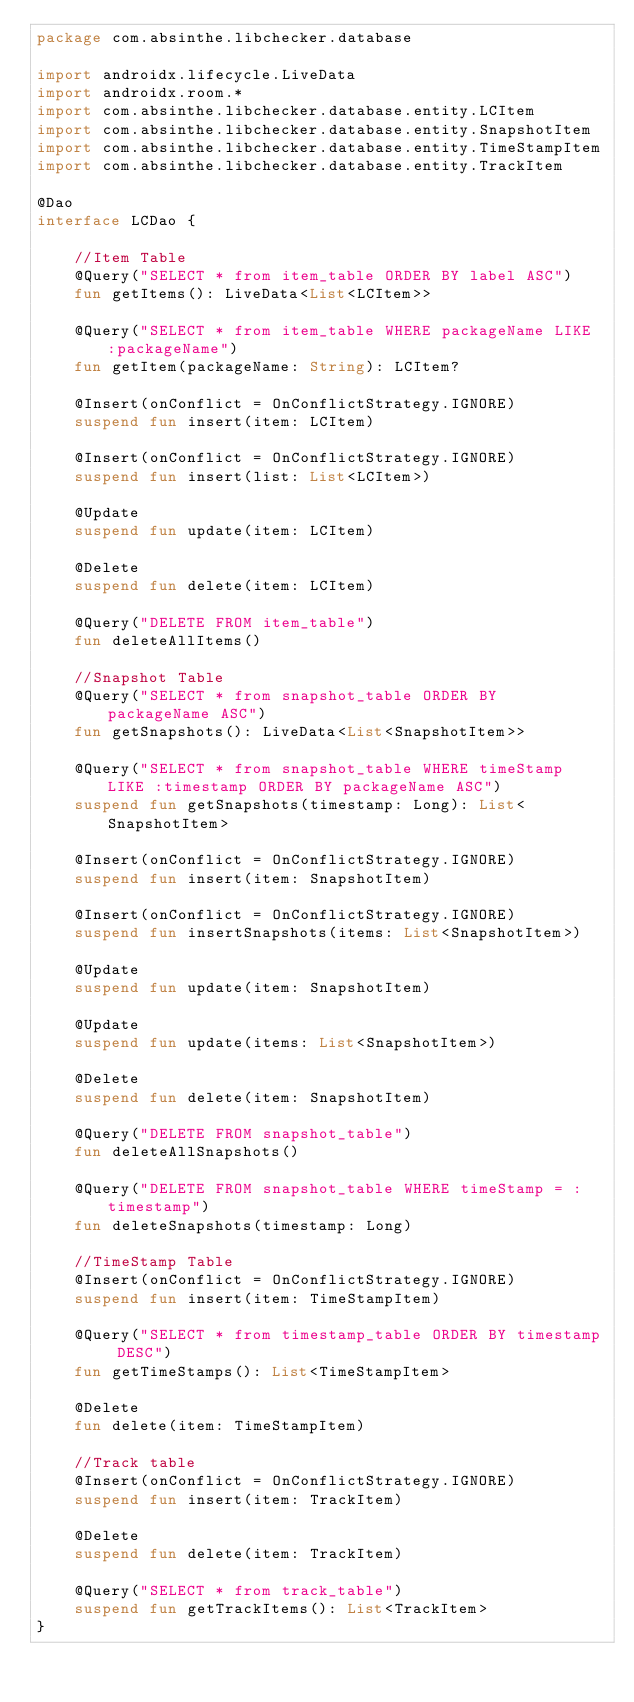<code> <loc_0><loc_0><loc_500><loc_500><_Kotlin_>package com.absinthe.libchecker.database

import androidx.lifecycle.LiveData
import androidx.room.*
import com.absinthe.libchecker.database.entity.LCItem
import com.absinthe.libchecker.database.entity.SnapshotItem
import com.absinthe.libchecker.database.entity.TimeStampItem
import com.absinthe.libchecker.database.entity.TrackItem

@Dao
interface LCDao {

    //Item Table
    @Query("SELECT * from item_table ORDER BY label ASC")
    fun getItems(): LiveData<List<LCItem>>

    @Query("SELECT * from item_table WHERE packageName LIKE :packageName")
    fun getItem(packageName: String): LCItem?

    @Insert(onConflict = OnConflictStrategy.IGNORE)
    suspend fun insert(item: LCItem)

    @Insert(onConflict = OnConflictStrategy.IGNORE)
    suspend fun insert(list: List<LCItem>)

    @Update
    suspend fun update(item: LCItem)

    @Delete
    suspend fun delete(item: LCItem)

    @Query("DELETE FROM item_table")
    fun deleteAllItems()

    //Snapshot Table
    @Query("SELECT * from snapshot_table ORDER BY packageName ASC")
    fun getSnapshots(): LiveData<List<SnapshotItem>>

    @Query("SELECT * from snapshot_table WHERE timeStamp LIKE :timestamp ORDER BY packageName ASC")
    suspend fun getSnapshots(timestamp: Long): List<SnapshotItem>

    @Insert(onConflict = OnConflictStrategy.IGNORE)
    suspend fun insert(item: SnapshotItem)

    @Insert(onConflict = OnConflictStrategy.IGNORE)
    suspend fun insertSnapshots(items: List<SnapshotItem>)

    @Update
    suspend fun update(item: SnapshotItem)

    @Update
    suspend fun update(items: List<SnapshotItem>)

    @Delete
    suspend fun delete(item: SnapshotItem)

    @Query("DELETE FROM snapshot_table")
    fun deleteAllSnapshots()

    @Query("DELETE FROM snapshot_table WHERE timeStamp = :timestamp")
    fun deleteSnapshots(timestamp: Long)

    //TimeStamp Table
    @Insert(onConflict = OnConflictStrategy.IGNORE)
    suspend fun insert(item: TimeStampItem)

    @Query("SELECT * from timestamp_table ORDER BY timestamp DESC")
    fun getTimeStamps(): List<TimeStampItem>

    @Delete
    fun delete(item: TimeStampItem)

    //Track table
    @Insert(onConflict = OnConflictStrategy.IGNORE)
    suspend fun insert(item: TrackItem)

    @Delete
    suspend fun delete(item: TrackItem)

    @Query("SELECT * from track_table")
    suspend fun getTrackItems(): List<TrackItem>
}</code> 